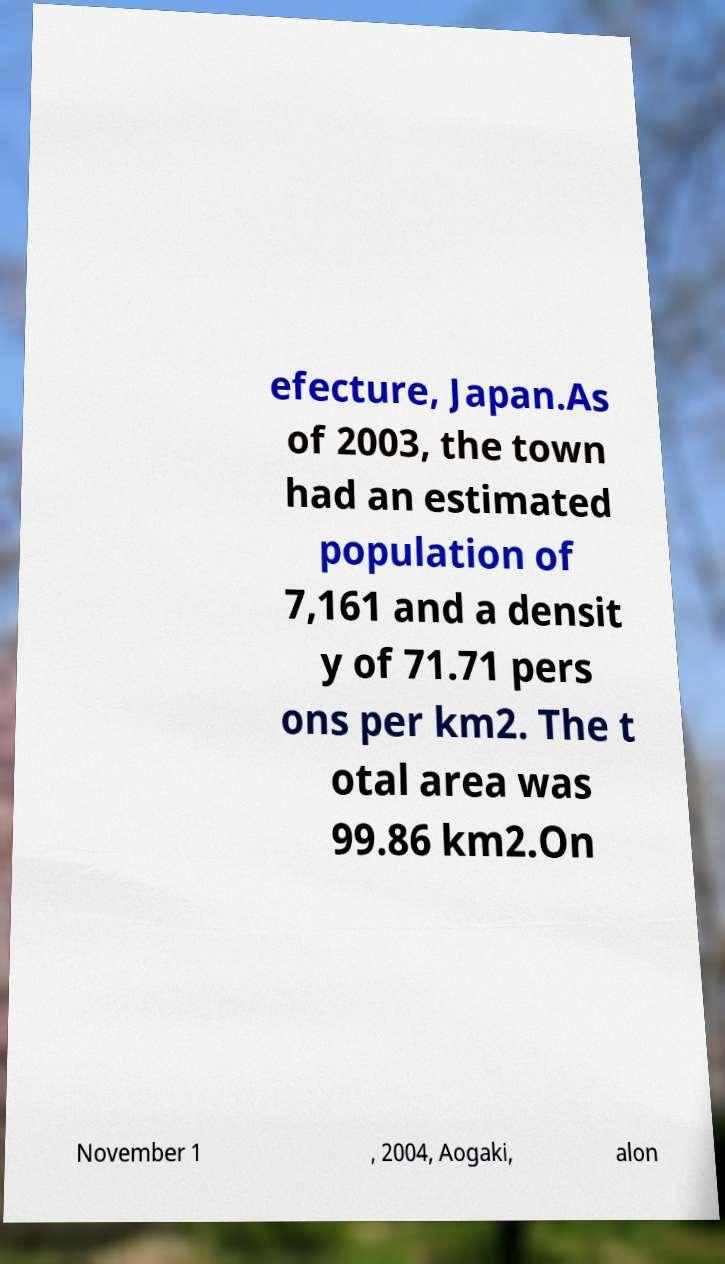Could you assist in decoding the text presented in this image and type it out clearly? efecture, Japan.As of 2003, the town had an estimated population of 7,161 and a densit y of 71.71 pers ons per km2. The t otal area was 99.86 km2.On November 1 , 2004, Aogaki, alon 